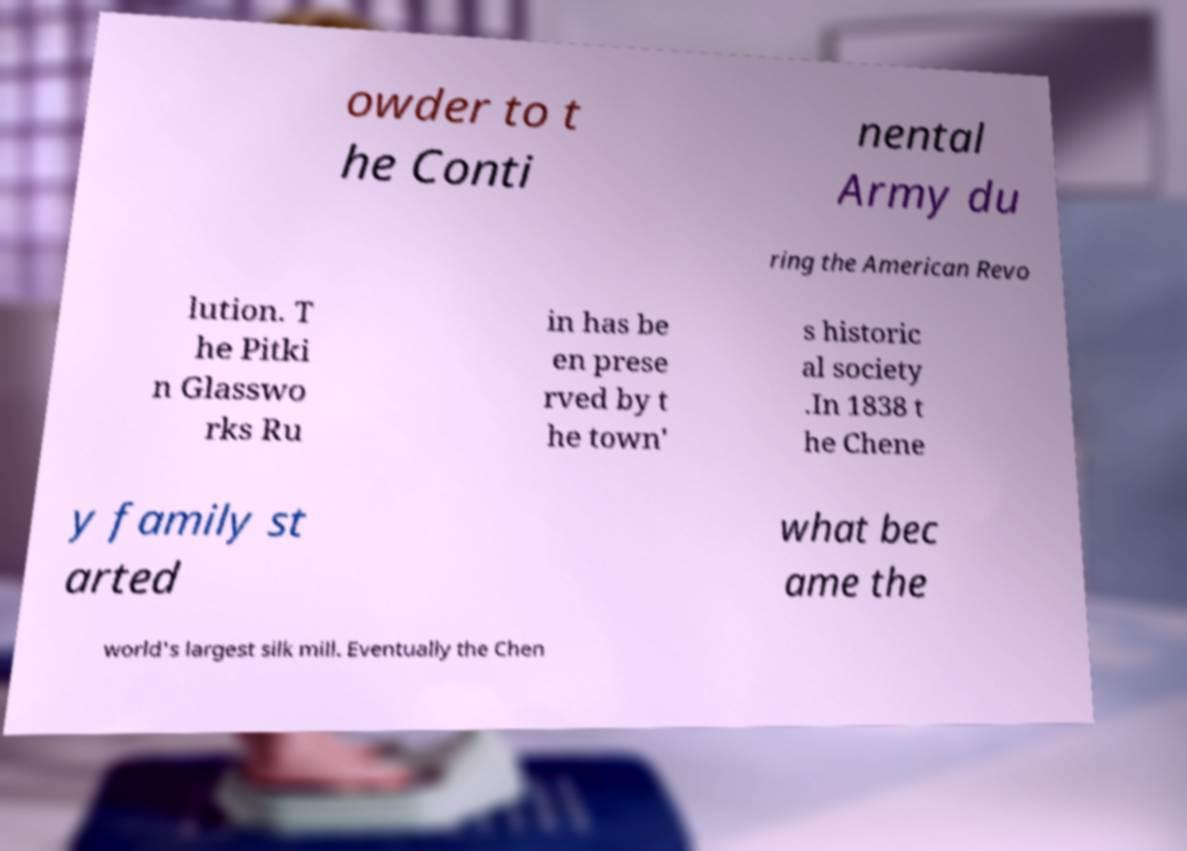There's text embedded in this image that I need extracted. Can you transcribe it verbatim? owder to t he Conti nental Army du ring the American Revo lution. T he Pitki n Glasswo rks Ru in has be en prese rved by t he town' s historic al society .In 1838 t he Chene y family st arted what bec ame the world's largest silk mill. Eventually the Chen 